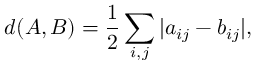<formula> <loc_0><loc_0><loc_500><loc_500>d ( A , B ) = \frac { 1 } { 2 } \sum _ { i , j } | a _ { i j } - b _ { i j } | ,</formula> 